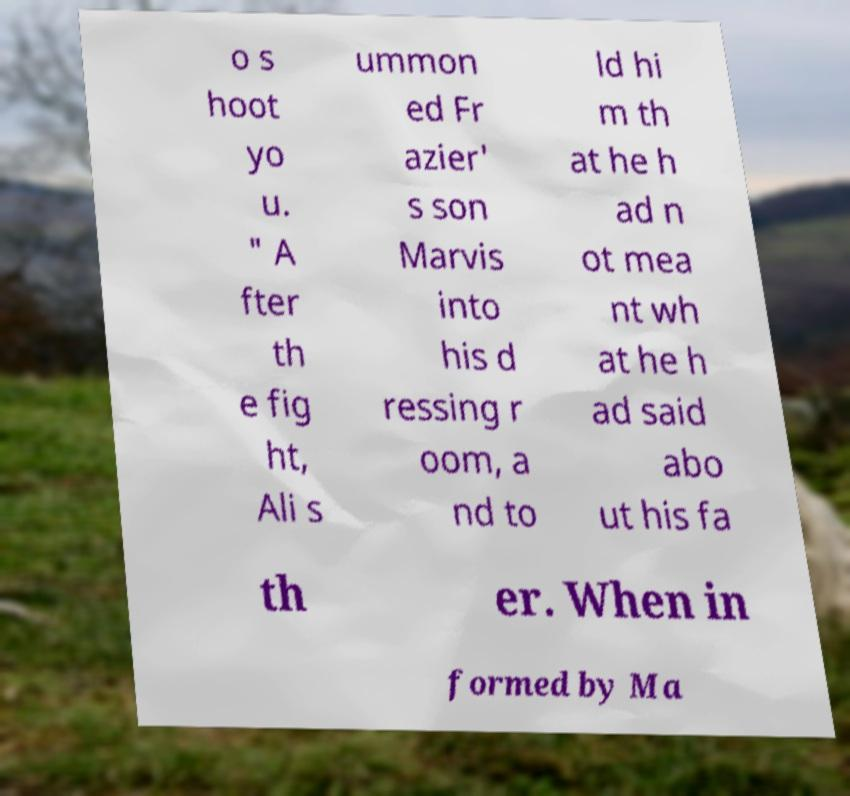I need the written content from this picture converted into text. Can you do that? o s hoot yo u. " A fter th e fig ht, Ali s ummon ed Fr azier' s son Marvis into his d ressing r oom, a nd to ld hi m th at he h ad n ot mea nt wh at he h ad said abo ut his fa th er. When in formed by Ma 